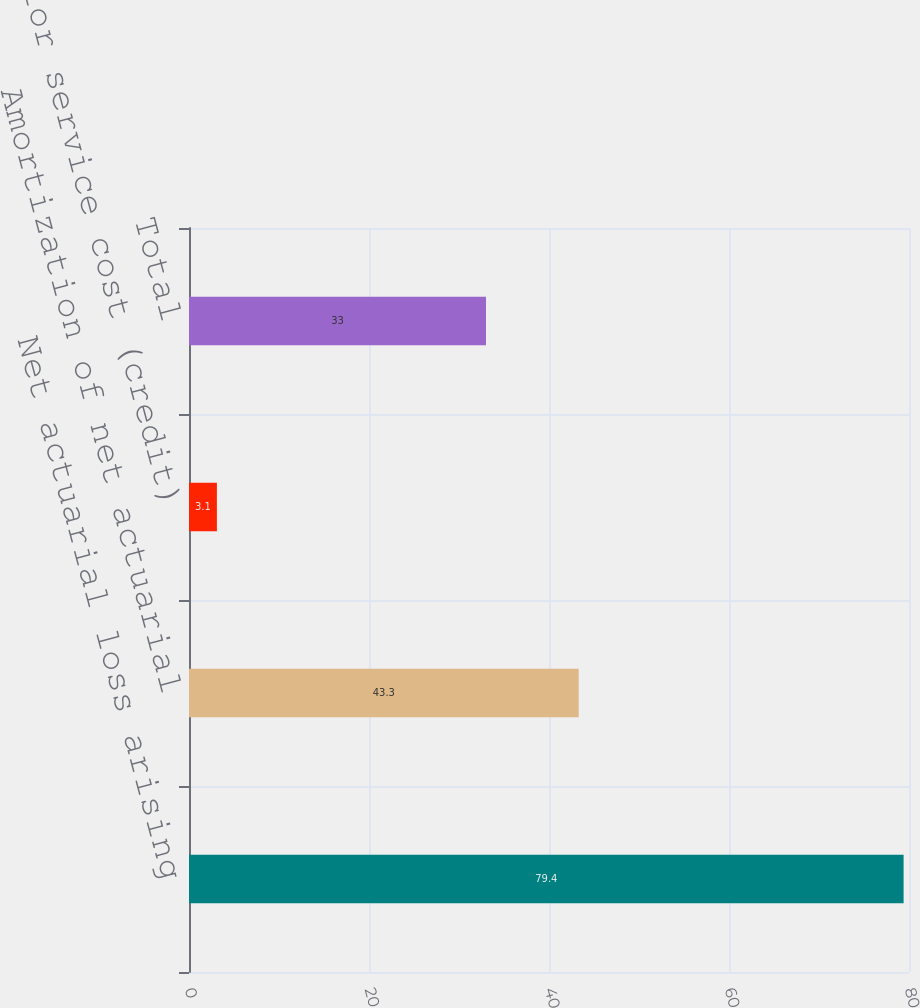<chart> <loc_0><loc_0><loc_500><loc_500><bar_chart><fcel>Net actuarial loss arising<fcel>Amortization of net actuarial<fcel>Prior service cost (credit)<fcel>Total<nl><fcel>79.4<fcel>43.3<fcel>3.1<fcel>33<nl></chart> 